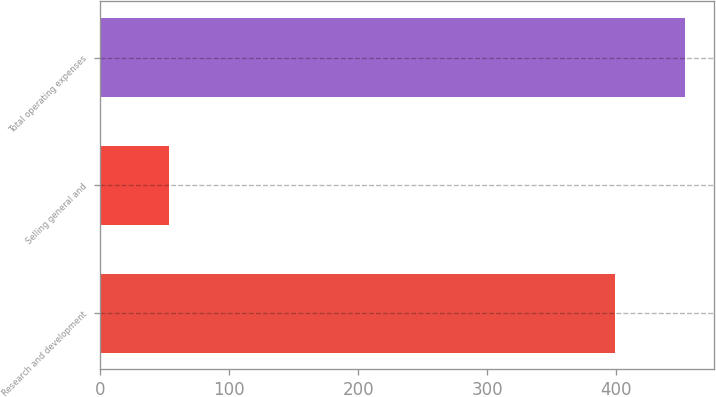Convert chart. <chart><loc_0><loc_0><loc_500><loc_500><bar_chart><fcel>Research and development<fcel>Selling general and<fcel>Total operating expenses<nl><fcel>398.8<fcel>52.9<fcel>453.4<nl></chart> 